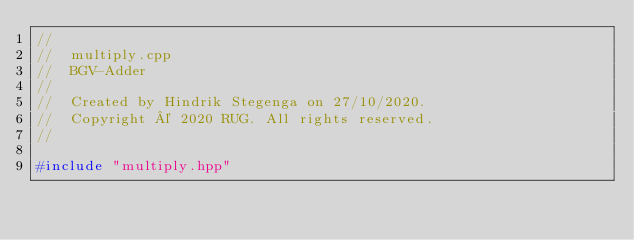Convert code to text. <code><loc_0><loc_0><loc_500><loc_500><_C++_>//
//  multiply.cpp
//  BGV-Adder
//
//  Created by Hindrik Stegenga on 27/10/2020.
//  Copyright © 2020 RUG. All rights reserved.
//

#include "multiply.hpp"</code> 